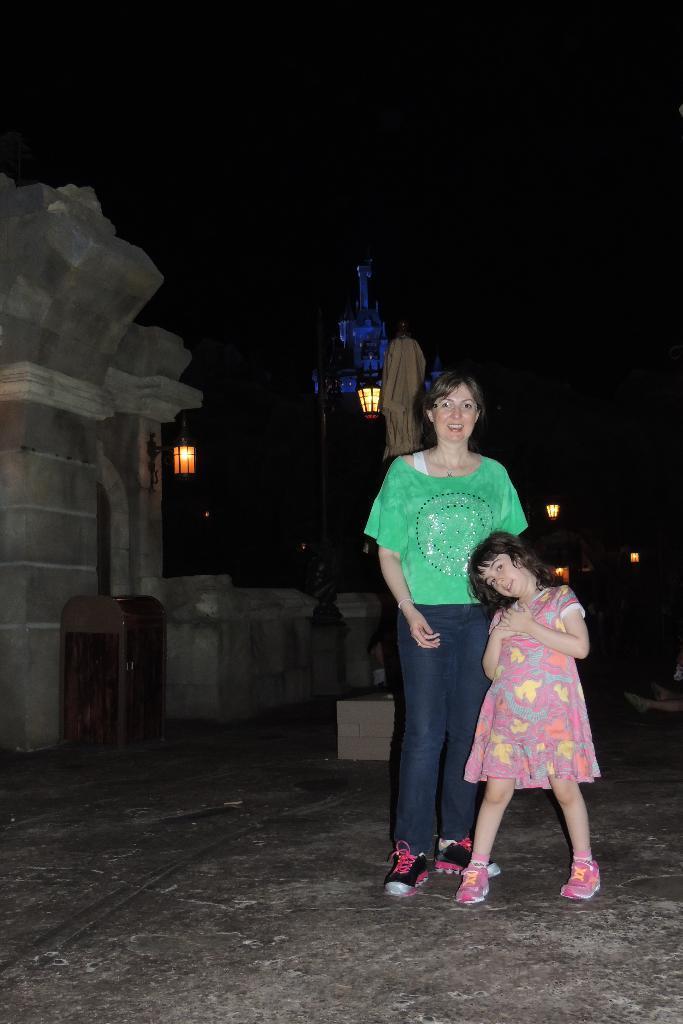In one or two sentences, can you explain what this image depicts? In this image I can see a woman and a girl. I can see both of them are standing and both of them are wearing shoes. I can also see one of them is wearing a green colour top, a jeans and another one is wearing pink colour dress. In the background I can see a sculpture, two buildings, few lights and on the left side I can see an object on the ground. I can also see this image is little bit in dark. 